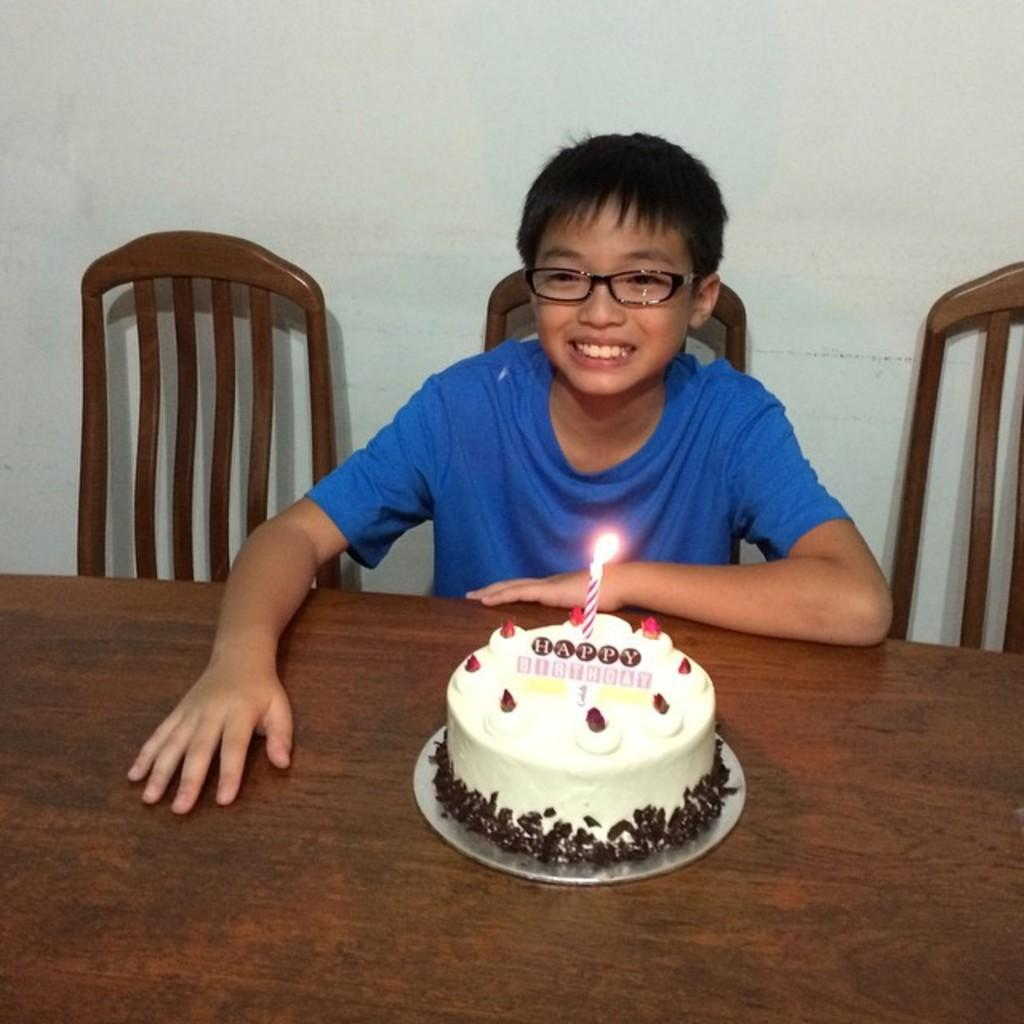Who is the main subject in the image? There is a boy in the image. What is the boy doing in the image? The boy is sitting on a chair. What is on the table in the image? The table contains a cake with a candle on it. How many chairs are visible in the image? There are empty chairs visible in the image. What can be seen in the background of the image? There is a wall in the background of the image. What type of list is the boy holding in the image? There is no list present in the image; the boy is sitting on a chair and there is a cake with a candle on the table. Is the boy wearing a mitten in the image? There is no mention of a mitten in the image; the boy is sitting on a chair and there is a cake with a candle on the table. 